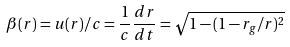Convert formula to latex. <formula><loc_0><loc_0><loc_500><loc_500>\beta ( r ) = u ( r ) / c = \frac { 1 } { c } \frac { d r } { d t } = \sqrt { 1 - ( 1 - r _ { g } / r ) ^ { 2 } }</formula> 